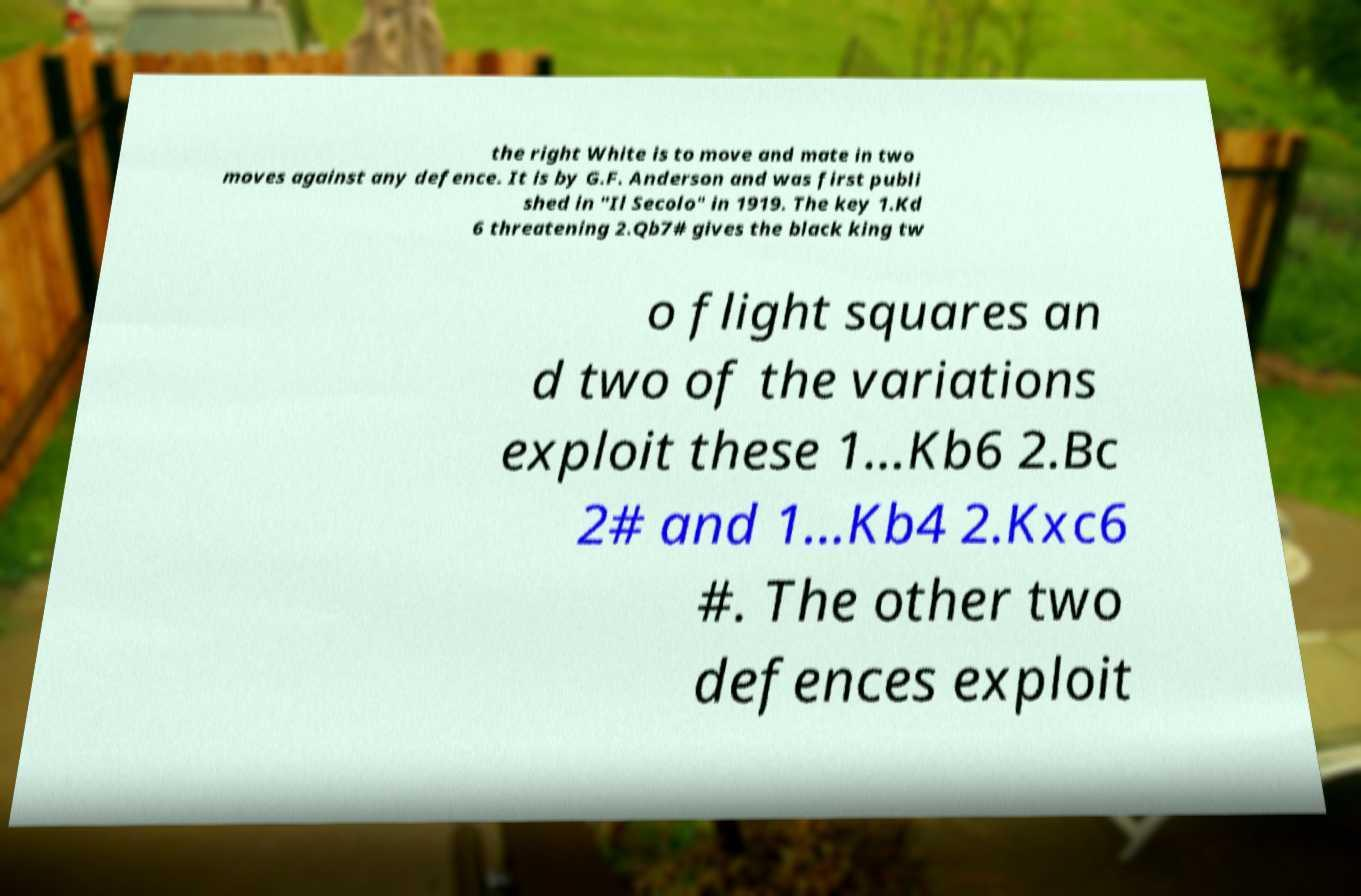Can you read and provide the text displayed in the image?This photo seems to have some interesting text. Can you extract and type it out for me? the right White is to move and mate in two moves against any defence. It is by G.F. Anderson and was first publi shed in "Il Secolo" in 1919. The key 1.Kd 6 threatening 2.Qb7# gives the black king tw o flight squares an d two of the variations exploit these 1...Kb6 2.Bc 2# and 1...Kb4 2.Kxc6 #. The other two defences exploit 